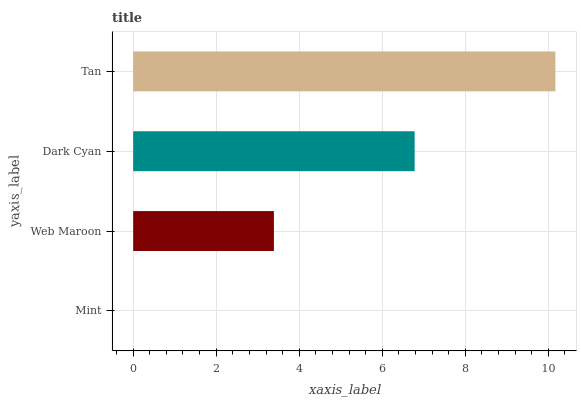Is Mint the minimum?
Answer yes or no. Yes. Is Tan the maximum?
Answer yes or no. Yes. Is Web Maroon the minimum?
Answer yes or no. No. Is Web Maroon the maximum?
Answer yes or no. No. Is Web Maroon greater than Mint?
Answer yes or no. Yes. Is Mint less than Web Maroon?
Answer yes or no. Yes. Is Mint greater than Web Maroon?
Answer yes or no. No. Is Web Maroon less than Mint?
Answer yes or no. No. Is Dark Cyan the high median?
Answer yes or no. Yes. Is Web Maroon the low median?
Answer yes or no. Yes. Is Tan the high median?
Answer yes or no. No. Is Mint the low median?
Answer yes or no. No. 